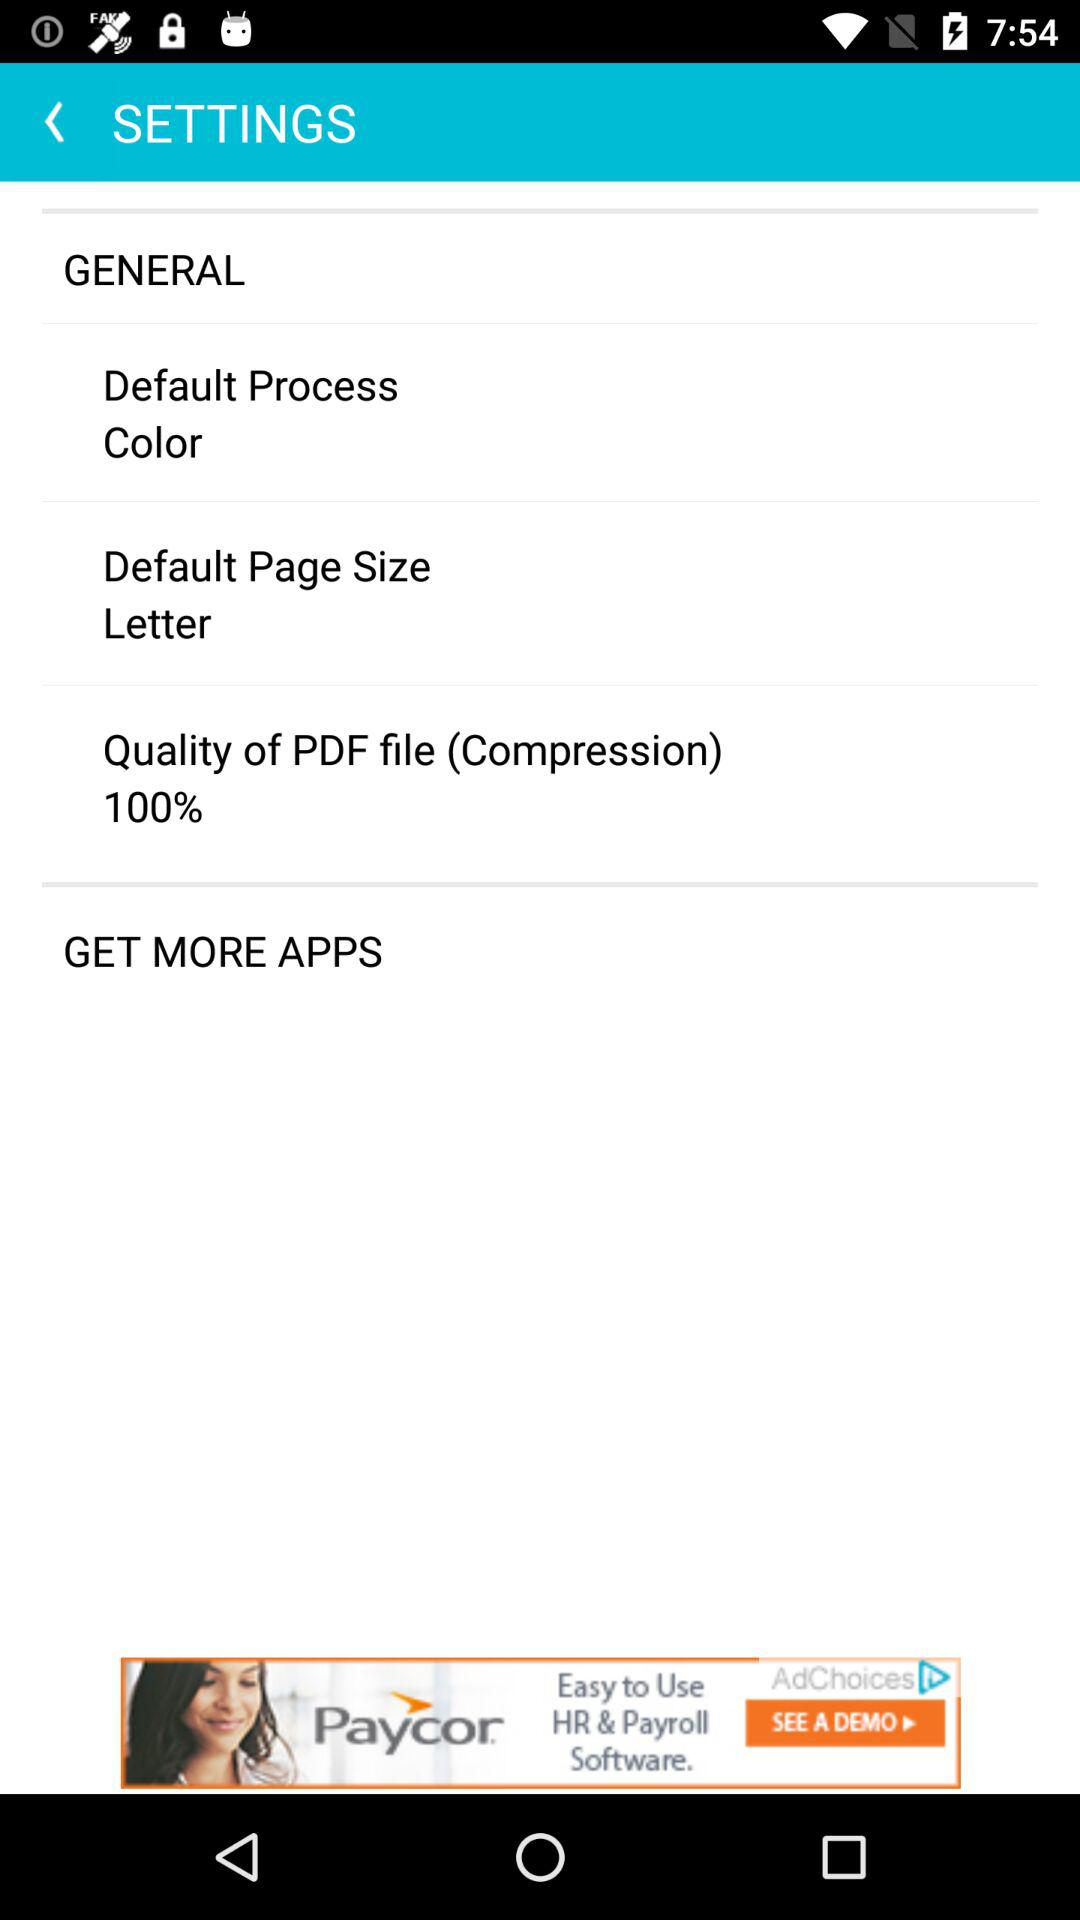What is the setting for the default process? The setting for the default process is "Color". 